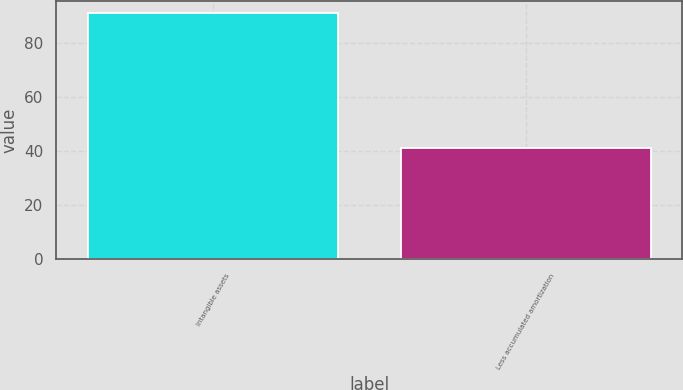Convert chart to OTSL. <chart><loc_0><loc_0><loc_500><loc_500><bar_chart><fcel>Intangible assets<fcel>Less accumulated amortization<nl><fcel>91<fcel>41<nl></chart> 